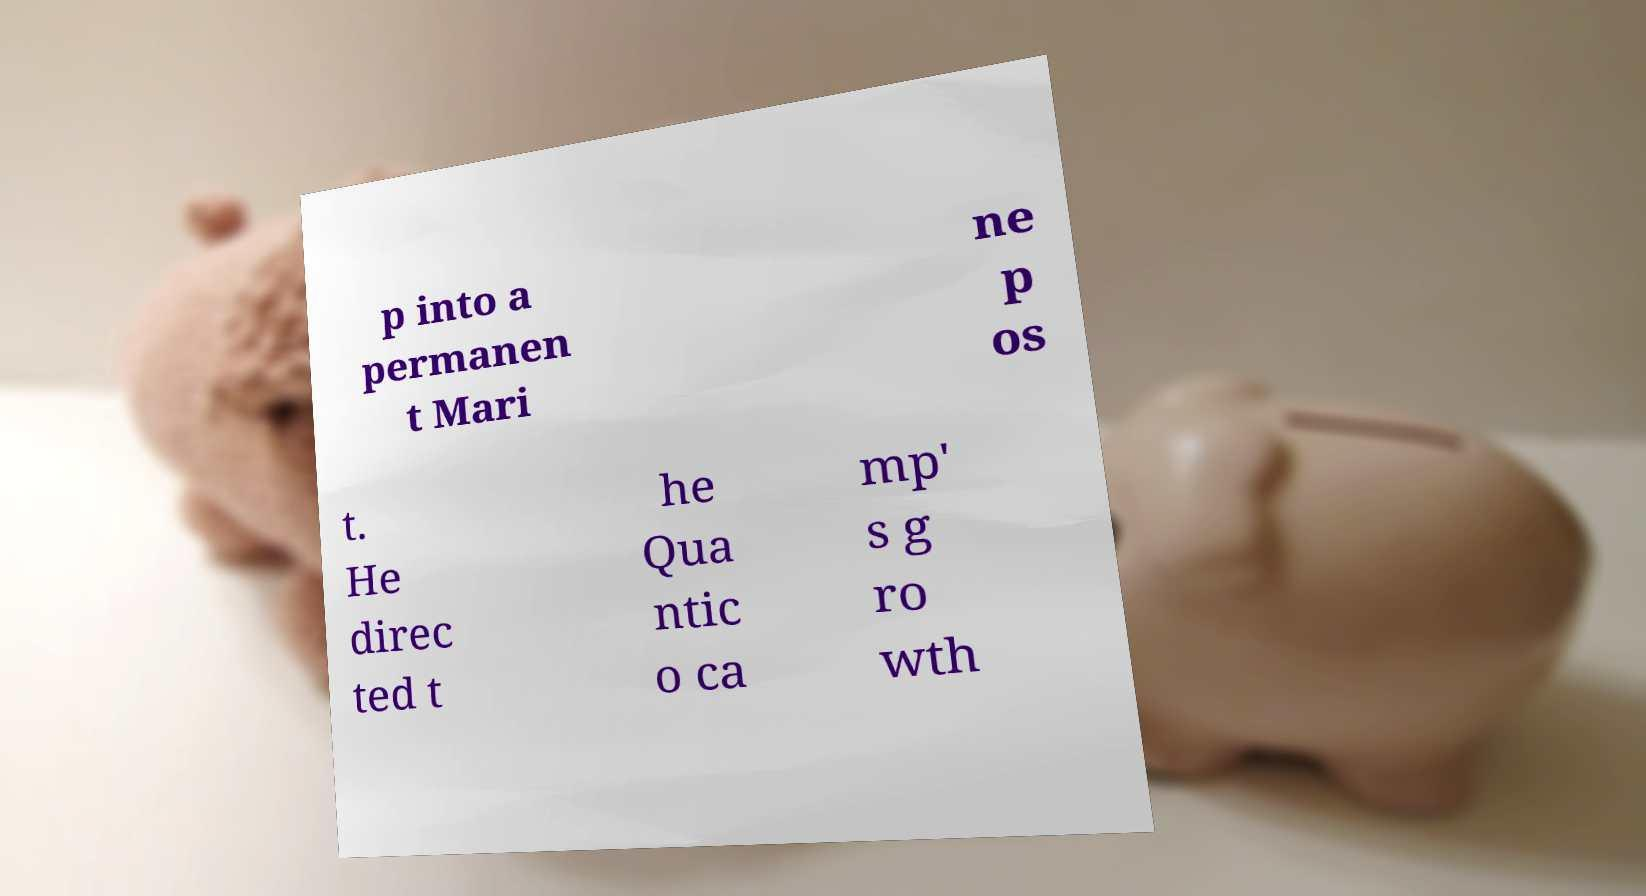I need the written content from this picture converted into text. Can you do that? p into a permanen t Mari ne p os t. He direc ted t he Qua ntic o ca mp' s g ro wth 